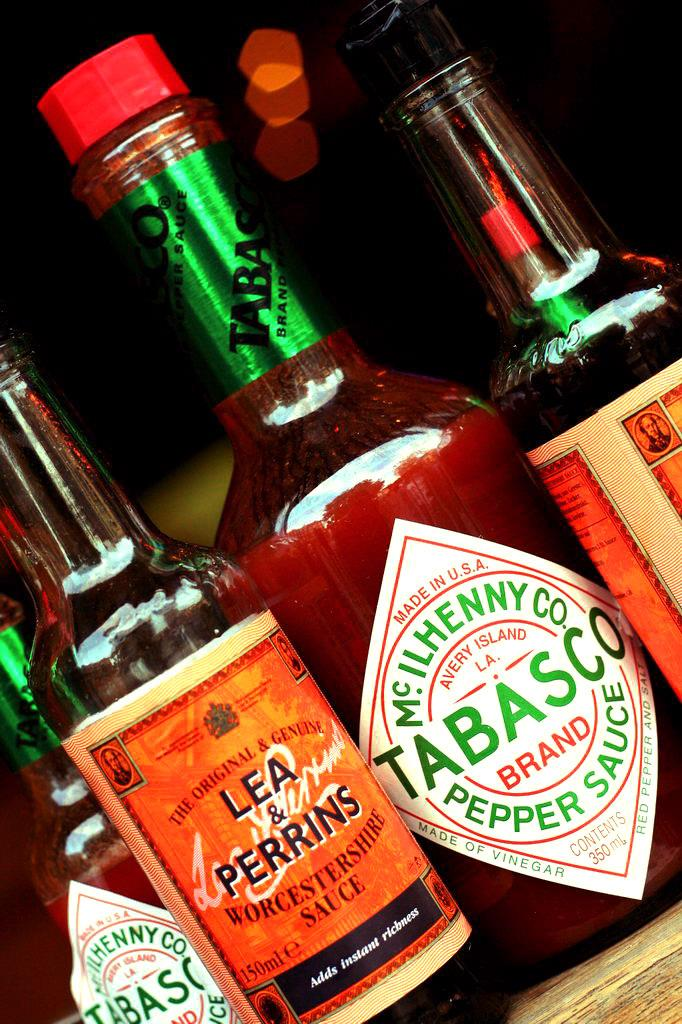How many sauce bottles are visible in the image? There are four sauce bottles in the image. Where are the sauce bottles located? The sauce bottles are placed on a table. What type of brass instrument is being played by the committee in the image? There is no brass instrument or committee present in the image; it only features four sauce bottles on a table. 